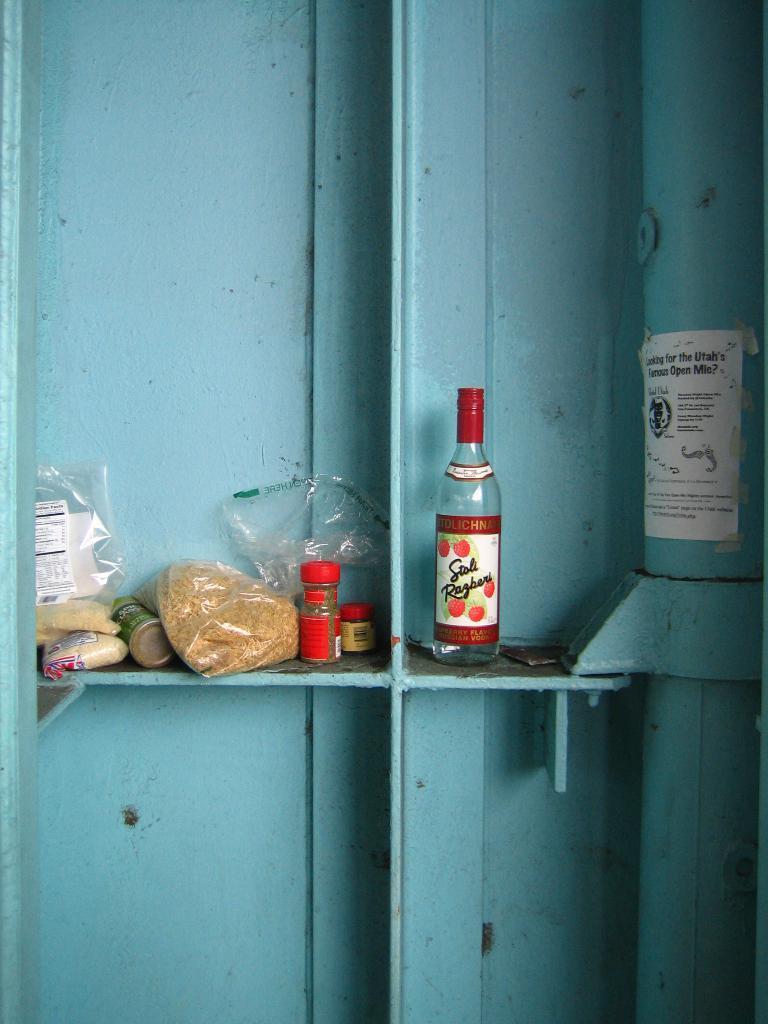How would you summarize this image in a sentence or two? Here we can see a bottle at the right side and at the left side we can see a plastic cover with some food and a plastic jar with something in it 